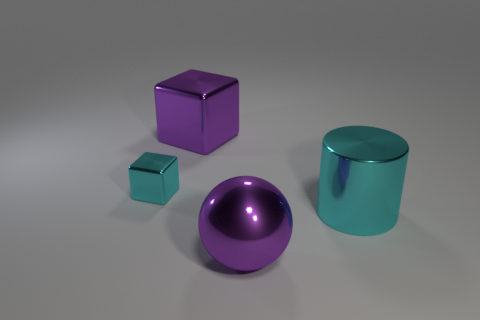What is the material of the purple object that is on the right side of the purple metallic thing behind the tiny shiny block behind the metal cylinder?
Ensure brevity in your answer.  Metal. How many metal things are in front of the purple metal cube and right of the small thing?
Make the answer very short. 2. There is a large shiny sphere that is to the right of the metal block on the left side of the large purple metallic block; what is its color?
Provide a short and direct response. Purple. Are there the same number of large purple metal balls that are on the right side of the big ball and cylinders?
Your answer should be very brief. No. What number of metal blocks are on the right side of the cyan metal thing to the left of the purple thing behind the big cyan metal cylinder?
Make the answer very short. 1. There is a metallic block behind the small cyan metal object; what is its color?
Provide a succinct answer. Purple. The object that is both on the right side of the tiny cyan shiny block and on the left side of the purple metal sphere is made of what material?
Your response must be concise. Metal. What number of big metallic objects are in front of the metallic object that is right of the ball?
Offer a terse response. 1. The big cyan object has what shape?
Make the answer very short. Cylinder. What is the shape of the small thing that is the same material as the big cyan cylinder?
Provide a short and direct response. Cube. 